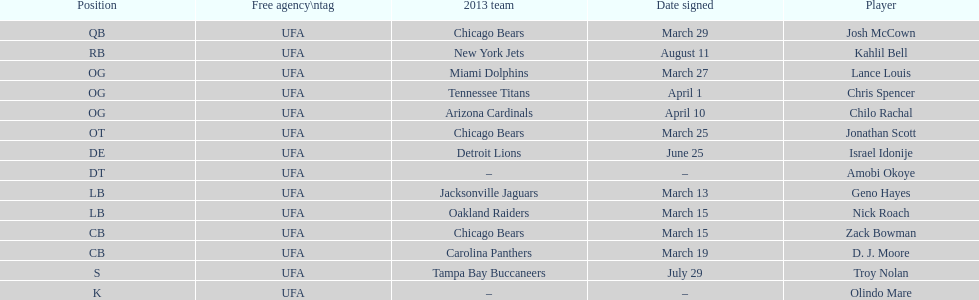His/her first name is the same name as a country. Israel Idonije. 